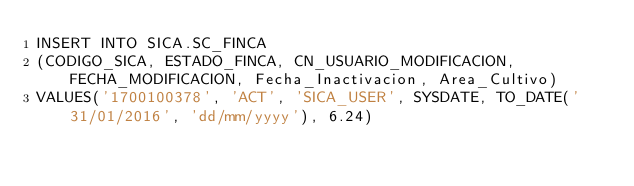Convert code to text. <code><loc_0><loc_0><loc_500><loc_500><_SQL_>INSERT INTO SICA.SC_FINCA
(CODIGO_SICA, ESTADO_FINCA, CN_USUARIO_MODIFICACION, FECHA_MODIFICACION, Fecha_Inactivacion, Area_Cultivo)
VALUES('1700100378', 'ACT', 'SICA_USER', SYSDATE, TO_DATE('31/01/2016', 'dd/mm/yyyy'), 6.24)</code> 